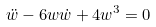Convert formula to latex. <formula><loc_0><loc_0><loc_500><loc_500>\ddot { w } - 6 w \dot { w } + 4 w ^ { 3 } = 0</formula> 